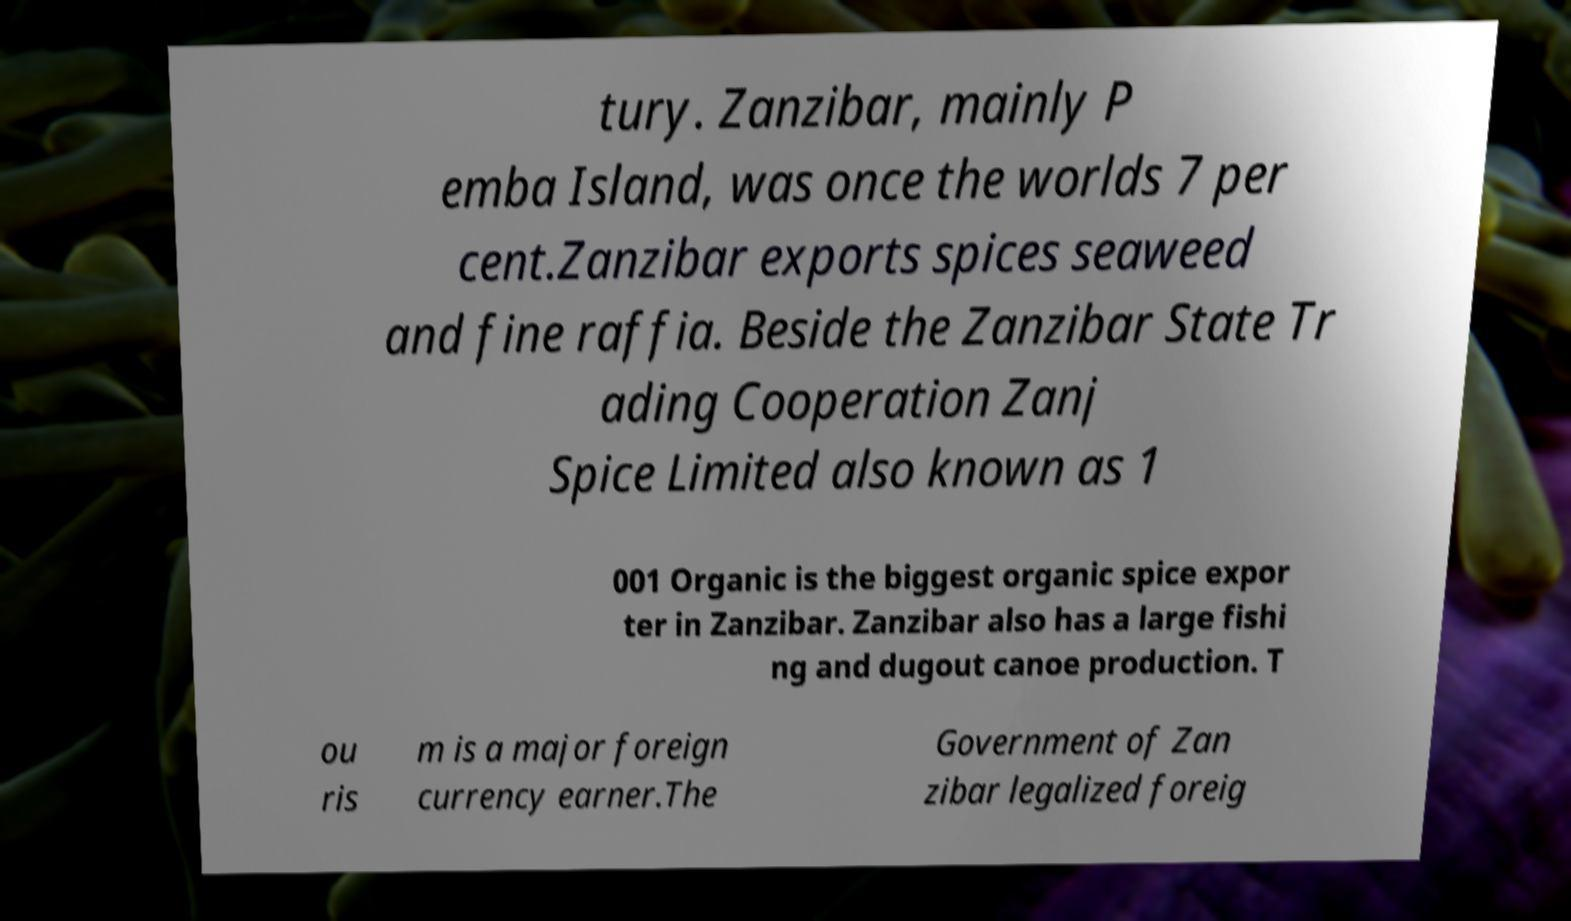Could you extract and type out the text from this image? tury. Zanzibar, mainly P emba Island, was once the worlds 7 per cent.Zanzibar exports spices seaweed and fine raffia. Beside the Zanzibar State Tr ading Cooperation Zanj Spice Limited also known as 1 001 Organic is the biggest organic spice expor ter in Zanzibar. Zanzibar also has a large fishi ng and dugout canoe production. T ou ris m is a major foreign currency earner.The Government of Zan zibar legalized foreig 